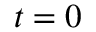Convert formula to latex. <formula><loc_0><loc_0><loc_500><loc_500>t = 0</formula> 